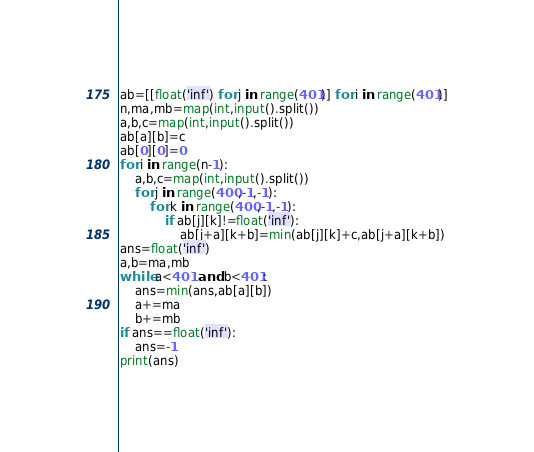<code> <loc_0><loc_0><loc_500><loc_500><_Python_>ab=[[float('inf') for j in range(401)] for i in range(401)]
n,ma,mb=map(int,input().split())
a,b,c=map(int,input().split())
ab[a][b]=c
ab[0][0]=0
for i in range(n-1):
    a,b,c=map(int,input().split())
    for j in range(400,-1,-1):
        for k in range(400,-1,-1):
            if ab[j][k]!=float('inf'):
                ab[j+a][k+b]=min(ab[j][k]+c,ab[j+a][k+b])
ans=float('inf')
a,b=ma,mb
while a<401 and b<401:
    ans=min(ans,ab[a][b])
    a+=ma
    b+=mb
if ans==float('inf'):
    ans=-1
print(ans)</code> 